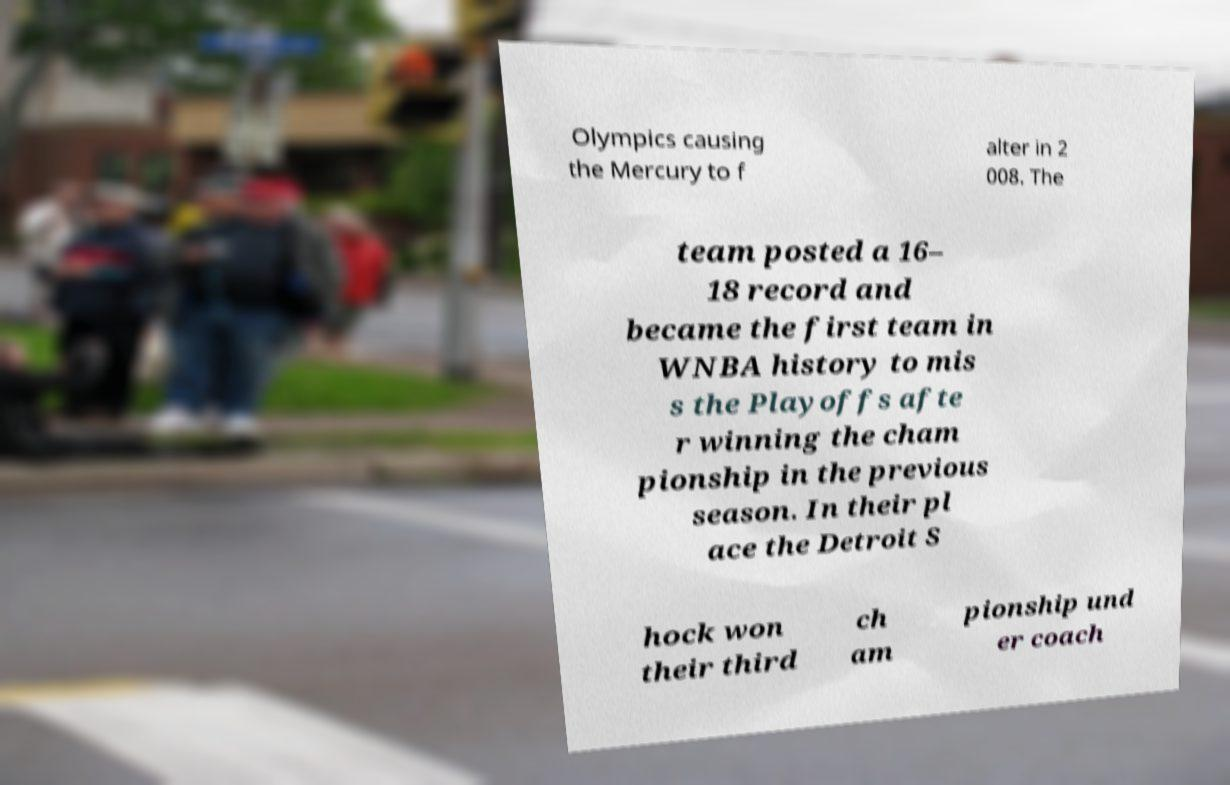Could you extract and type out the text from this image? Olympics causing the Mercury to f alter in 2 008. The team posted a 16– 18 record and became the first team in WNBA history to mis s the Playoffs afte r winning the cham pionship in the previous season. In their pl ace the Detroit S hock won their third ch am pionship und er coach 